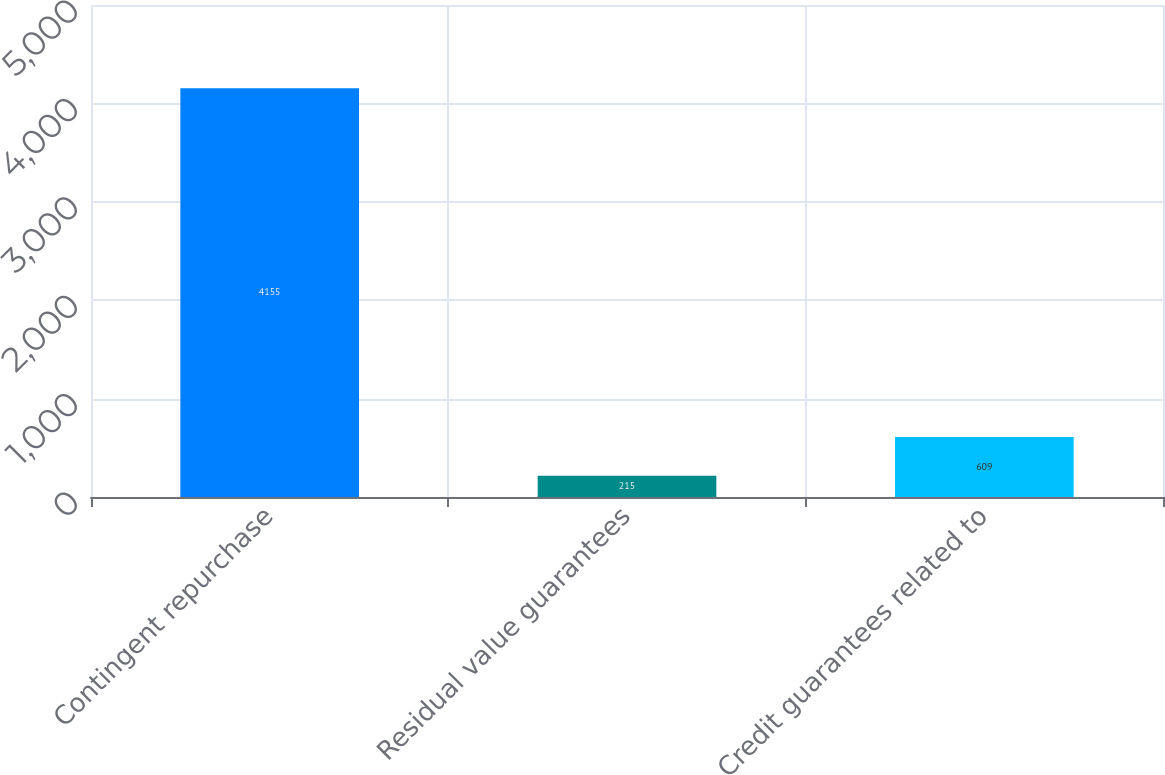Convert chart. <chart><loc_0><loc_0><loc_500><loc_500><bar_chart><fcel>Contingent repurchase<fcel>Residual value guarantees<fcel>Credit guarantees related to<nl><fcel>4155<fcel>215<fcel>609<nl></chart> 